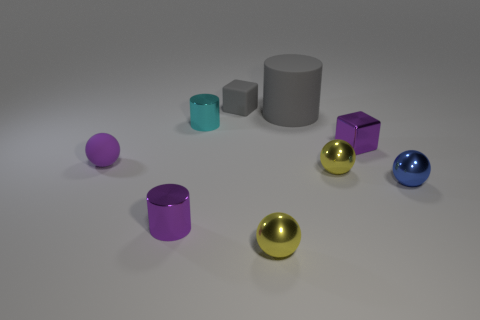Can you describe the lighting in the scene and the shadows cast by the objects? Soft, diffused lighting illuminates the scene from above, casting gentle and slightly elongated shadows that offer a soft contrast to the objects. The shadows help to anchor the objects in space, enhancing the three-dimensional feel of the image. 